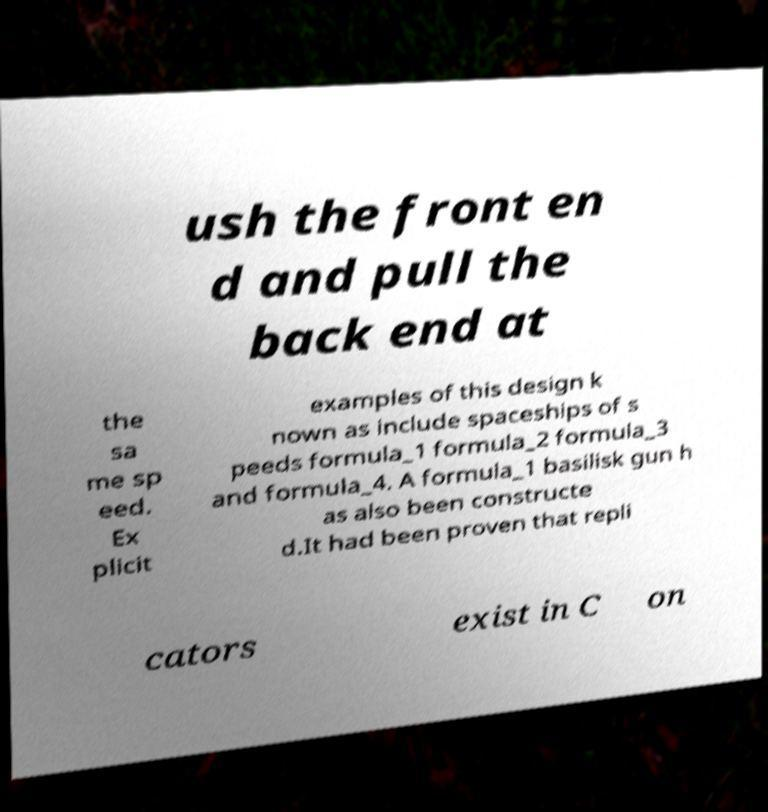For documentation purposes, I need the text within this image transcribed. Could you provide that? ush the front en d and pull the back end at the sa me sp eed. Ex plicit examples of this design k nown as include spaceships of s peeds formula_1 formula_2 formula_3 and formula_4. A formula_1 basilisk gun h as also been constructe d.It had been proven that repli cators exist in C on 